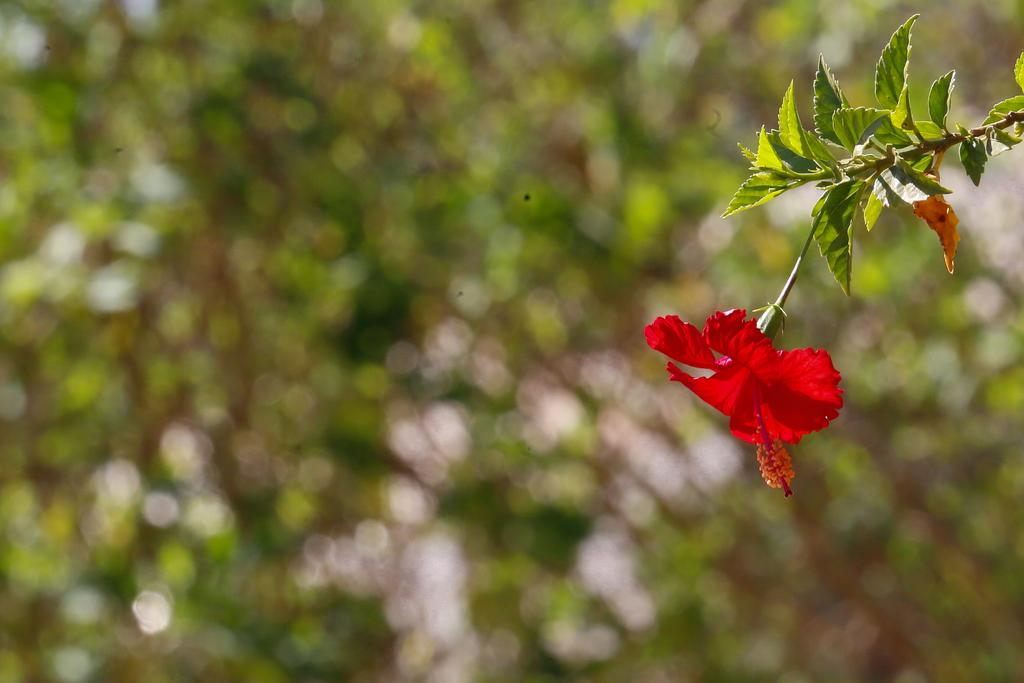What is the main subject in the front of the image? There is a flower in the front of the image. How would you describe the background of the image? The background of the image is blurry. What else can be seen in the front of the image besides the flower? Leaves are visible in the front of the image. What type of voice can be heard coming from the flower in the image? There is no voice present in the image, as flowers do not have the ability to produce sound. 